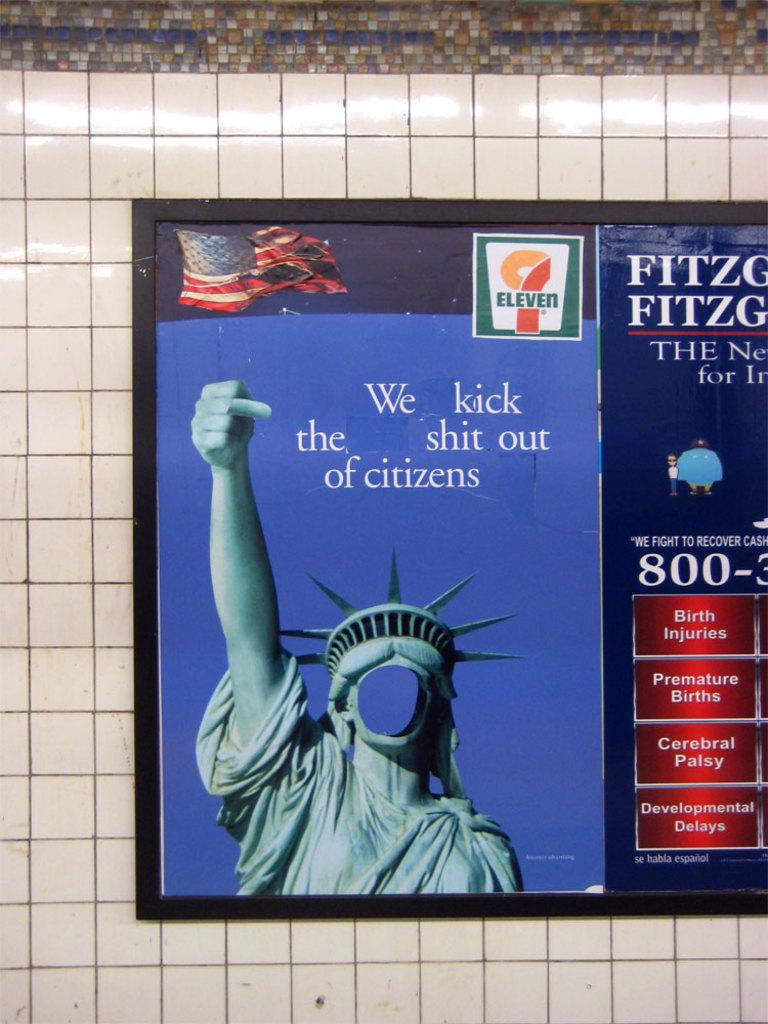<image>
Write a terse but informative summary of the picture. A poster of the statue of liberty has a 7-Eleven logo on it. 